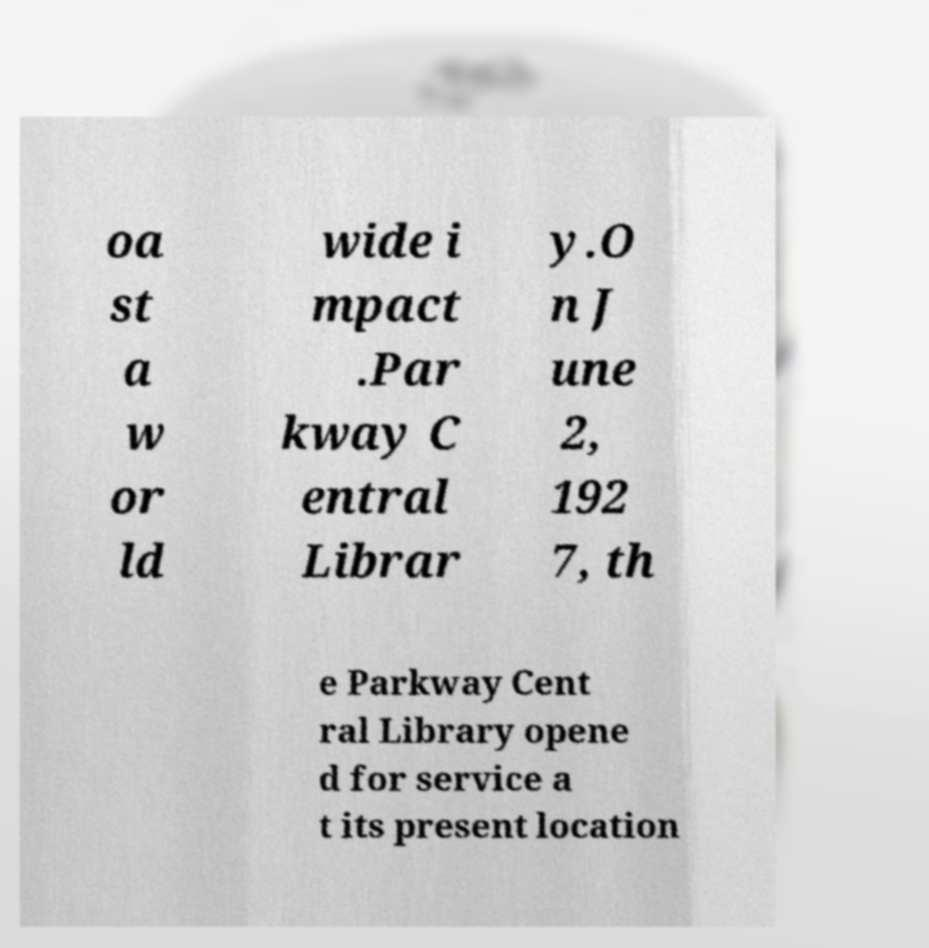Please read and relay the text visible in this image. What does it say? oa st a w or ld wide i mpact .Par kway C entral Librar y.O n J une 2, 192 7, th e Parkway Cent ral Library opene d for service a t its present location 